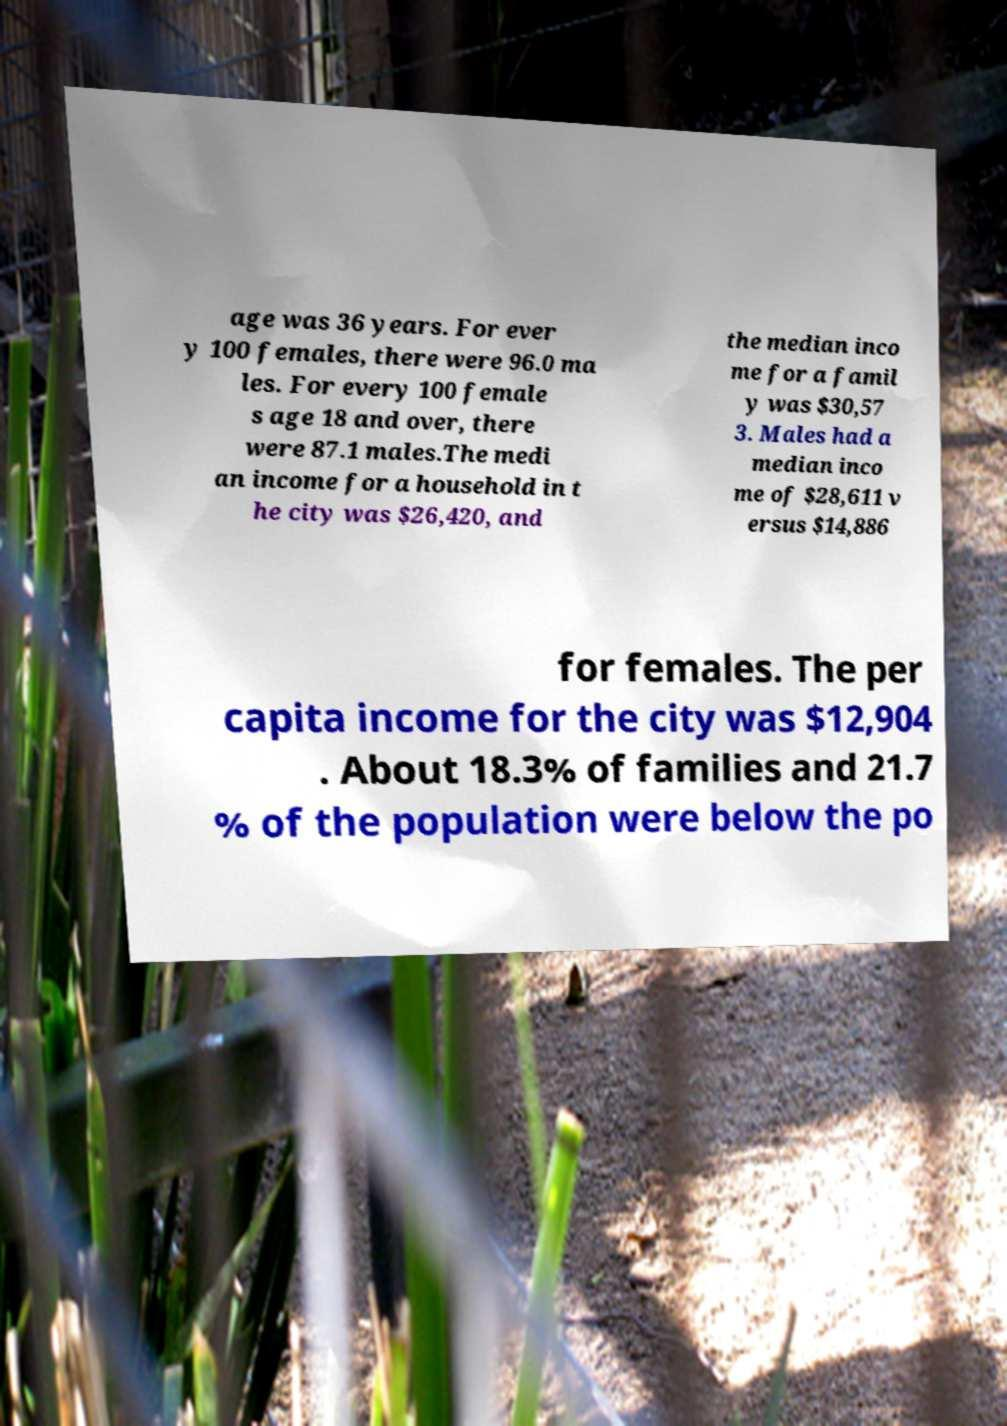Could you extract and type out the text from this image? age was 36 years. For ever y 100 females, there were 96.0 ma les. For every 100 female s age 18 and over, there were 87.1 males.The medi an income for a household in t he city was $26,420, and the median inco me for a famil y was $30,57 3. Males had a median inco me of $28,611 v ersus $14,886 for females. The per capita income for the city was $12,904 . About 18.3% of families and 21.7 % of the population were below the po 